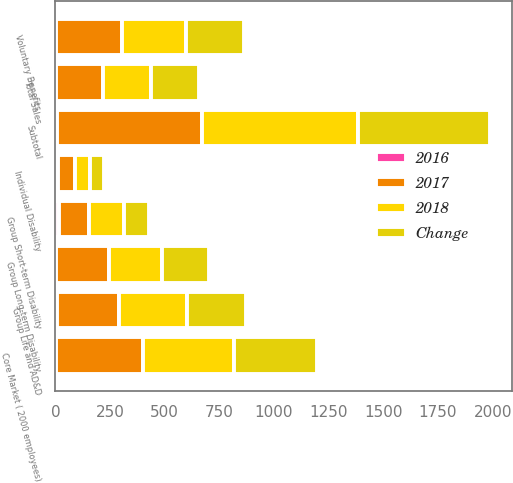<chart> <loc_0><loc_0><loc_500><loc_500><stacked_bar_chart><ecel><fcel>Group Long-term Disability<fcel>Group Short-term Disability<fcel>Group Life and AD&D<fcel>Subtotal<fcel>Individual Disability<fcel>Voluntary Benefits<fcel>Total Sales<fcel>Core Market ( 2000 employees)<nl><fcel>2017<fcel>243.8<fcel>138.7<fcel>282.4<fcel>664.9<fcel>77.2<fcel>303.1<fcel>217.8<fcel>395.1<nl><fcel>2016<fcel>1.2<fcel>14.6<fcel>9<fcel>6.9<fcel>13.7<fcel>3.6<fcel>1.3<fcel>5.2<nl><fcel>2018<fcel>240.8<fcel>162.5<fcel>310.5<fcel>713.8<fcel>67.9<fcel>292.5<fcel>217.8<fcel>416.9<nl><fcel>Change<fcel>217.8<fcel>114.6<fcel>270.1<fcel>602.5<fcel>65.1<fcel>261.7<fcel>217.8<fcel>378.1<nl></chart> 